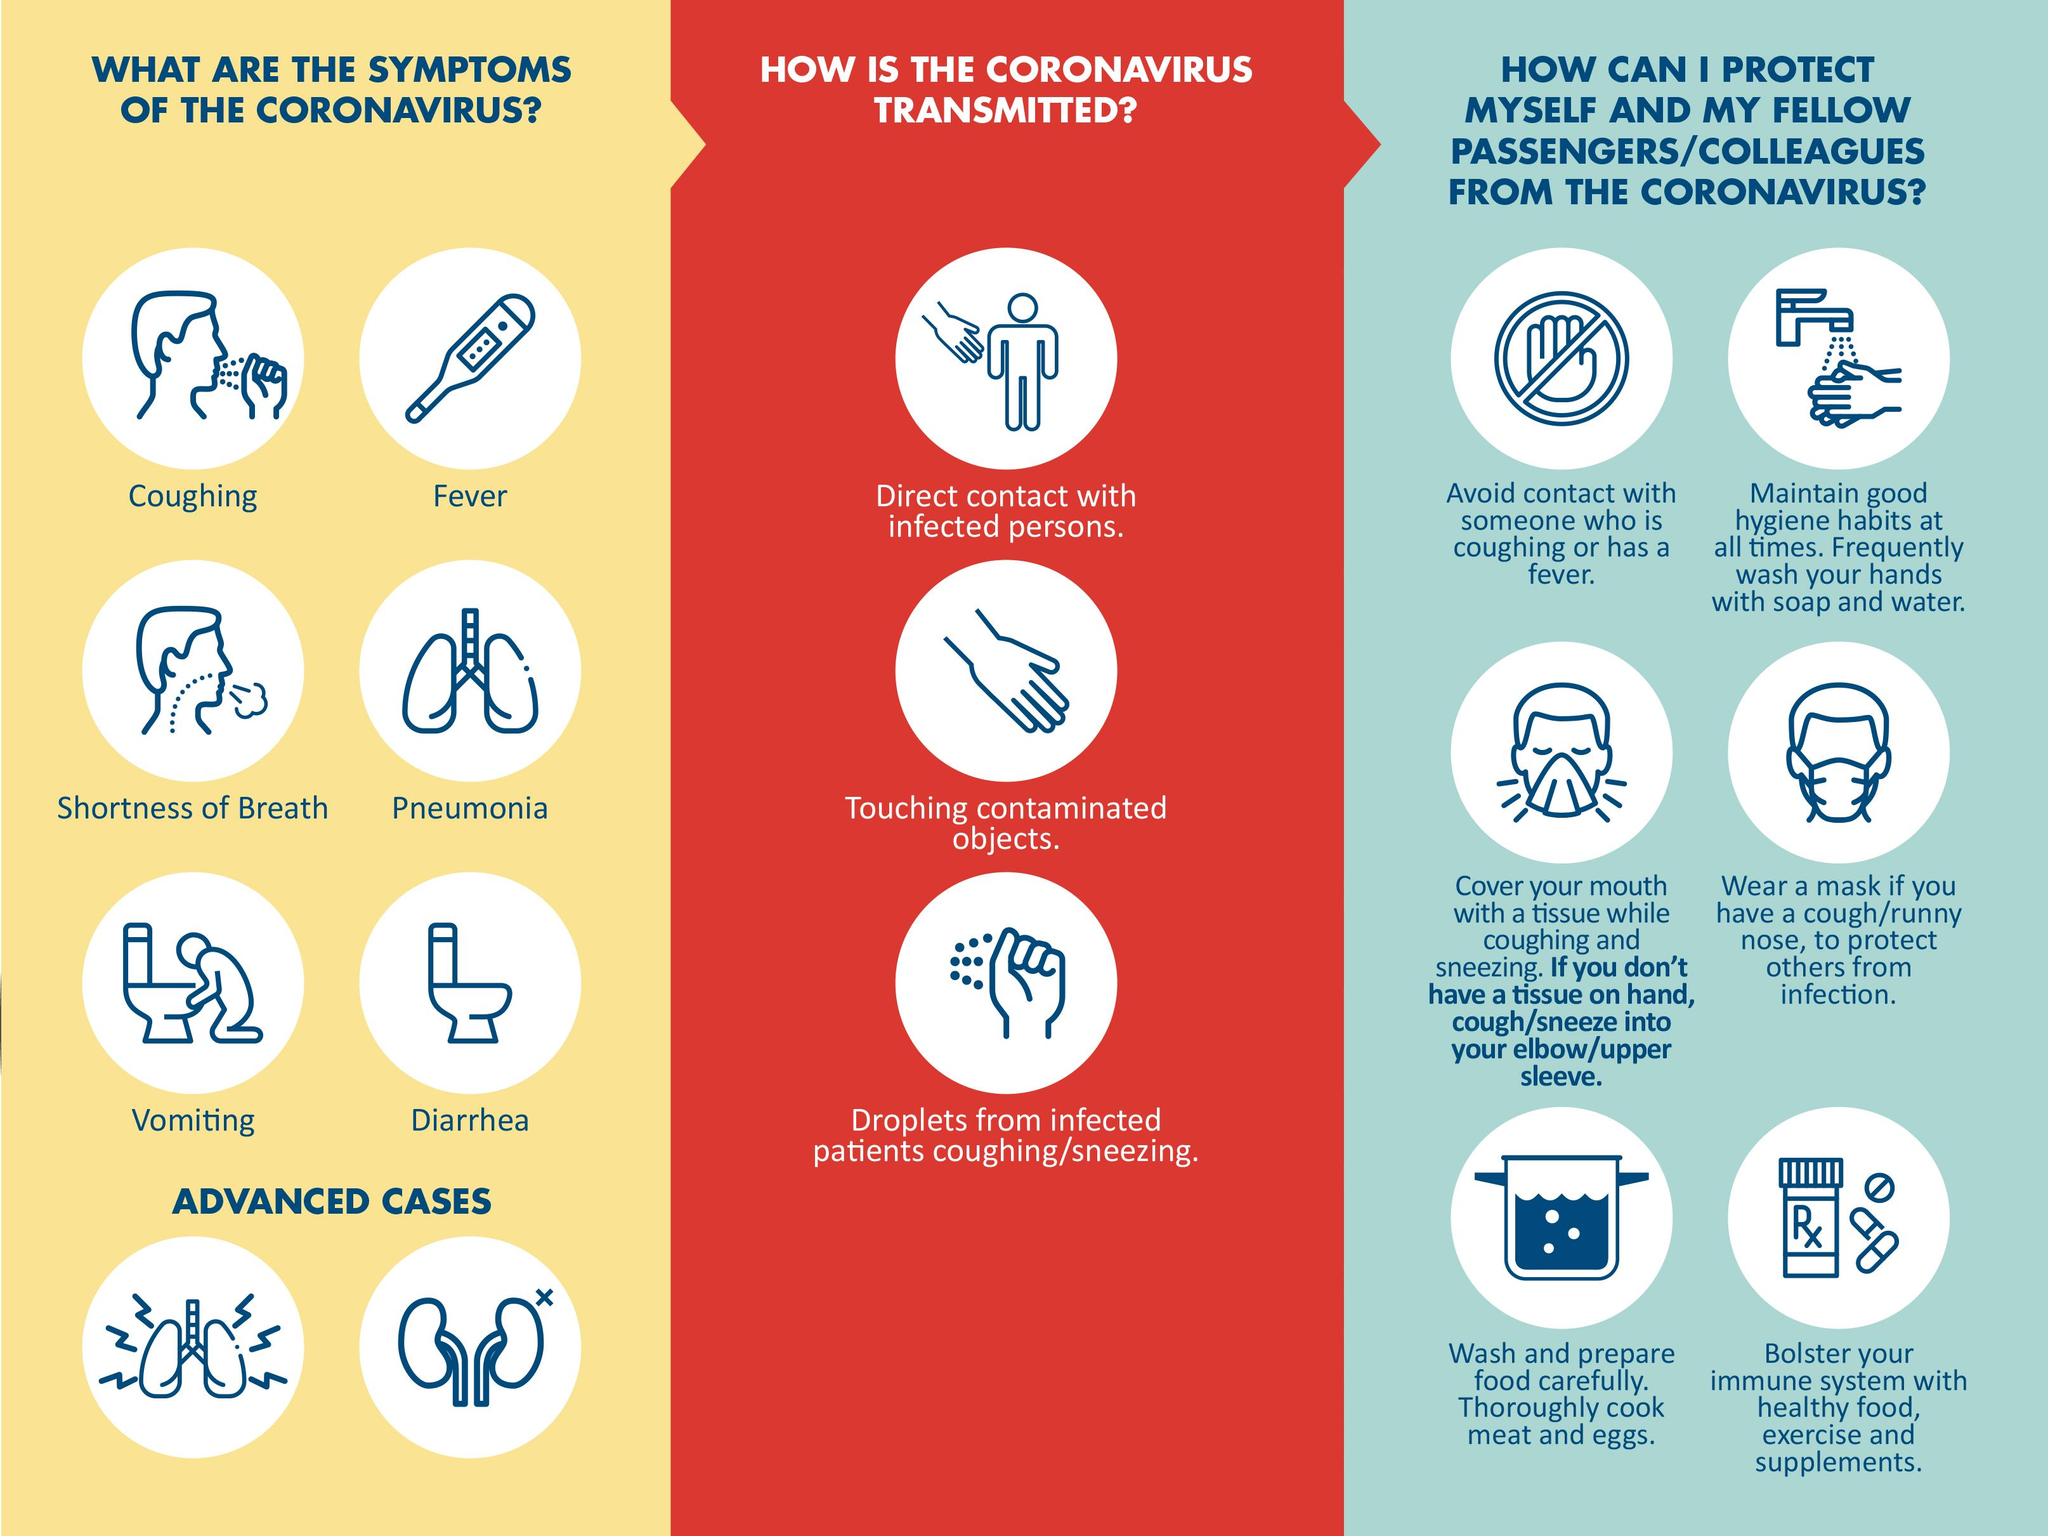Give some essential details in this illustration. The picture of the lung indicates the symptom of pneumonia. The coronavirus can be transmitted through three different ways. Eating healthy food, exercising regularly, and taking supplements can all help to strengthen the immune system. There are six symptoms of COVID-19 that have been reported. The thermometer indicates that there is a fever. 